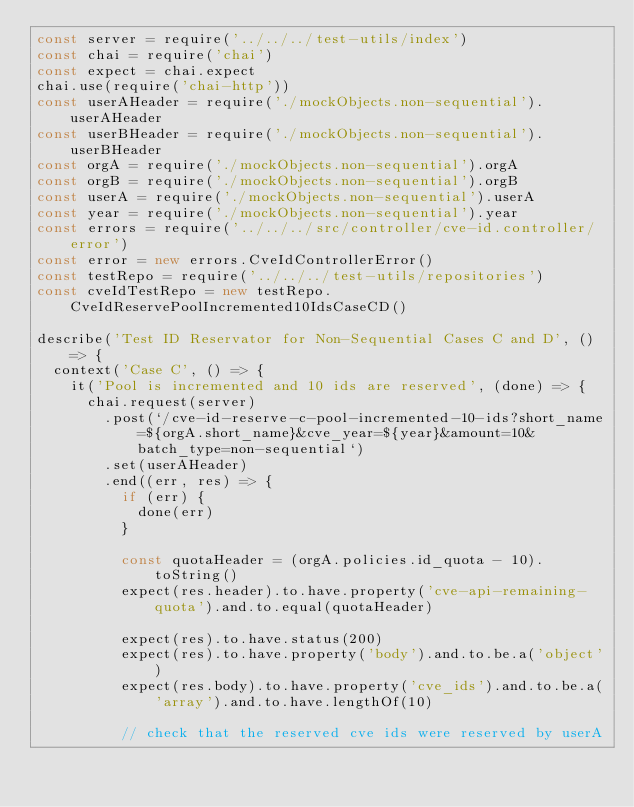<code> <loc_0><loc_0><loc_500><loc_500><_JavaScript_>const server = require('../../../test-utils/index')
const chai = require('chai')
const expect = chai.expect
chai.use(require('chai-http'))
const userAHeader = require('./mockObjects.non-sequential').userAHeader
const userBHeader = require('./mockObjects.non-sequential').userBHeader
const orgA = require('./mockObjects.non-sequential').orgA
const orgB = require('./mockObjects.non-sequential').orgB
const userA = require('./mockObjects.non-sequential').userA
const year = require('./mockObjects.non-sequential').year
const errors = require('../../../src/controller/cve-id.controller/error')
const error = new errors.CveIdControllerError()
const testRepo = require('../../../test-utils/repositories')
const cveIdTestRepo = new testRepo.CveIdReservePoolIncremented10IdsCaseCD()

describe('Test ID Reservator for Non-Sequential Cases C and D', () => {
  context('Case C', () => {
    it('Pool is incremented and 10 ids are reserved', (done) => {
      chai.request(server)
        .post(`/cve-id-reserve-c-pool-incremented-10-ids?short_name=${orgA.short_name}&cve_year=${year}&amount=10&batch_type=non-sequential`)
        .set(userAHeader)
        .end((err, res) => {
          if (err) {
            done(err)
          }

          const quotaHeader = (orgA.policies.id_quota - 10).toString()
          expect(res.header).to.have.property('cve-api-remaining-quota').and.to.equal(quotaHeader)

          expect(res).to.have.status(200)
          expect(res).to.have.property('body').and.to.be.a('object')
          expect(res.body).to.have.property('cve_ids').and.to.be.a('array').and.to.have.lengthOf(10)

          // check that the reserved cve ids were reserved by userA</code> 